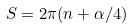Convert formula to latex. <formula><loc_0><loc_0><loc_500><loc_500>S = 2 \pi ( n + \alpha / 4 )</formula> 